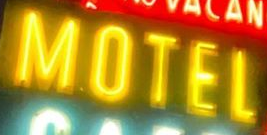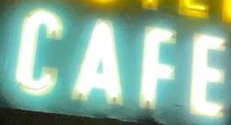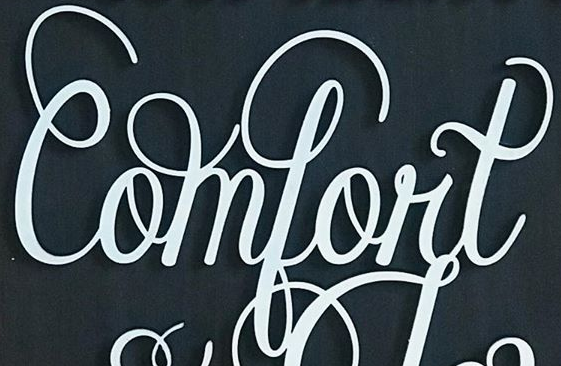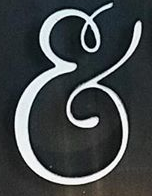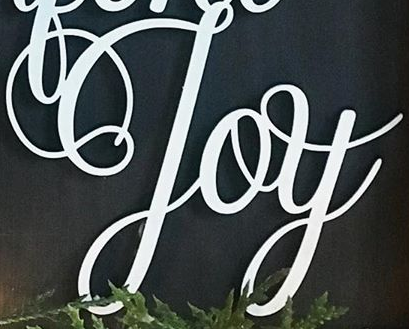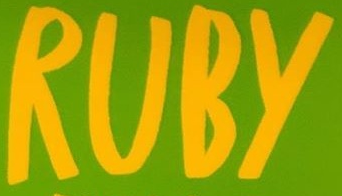Read the text from these images in sequence, separated by a semicolon. MOTEL; CAFE; Comfort; &; Joy; RUBY 